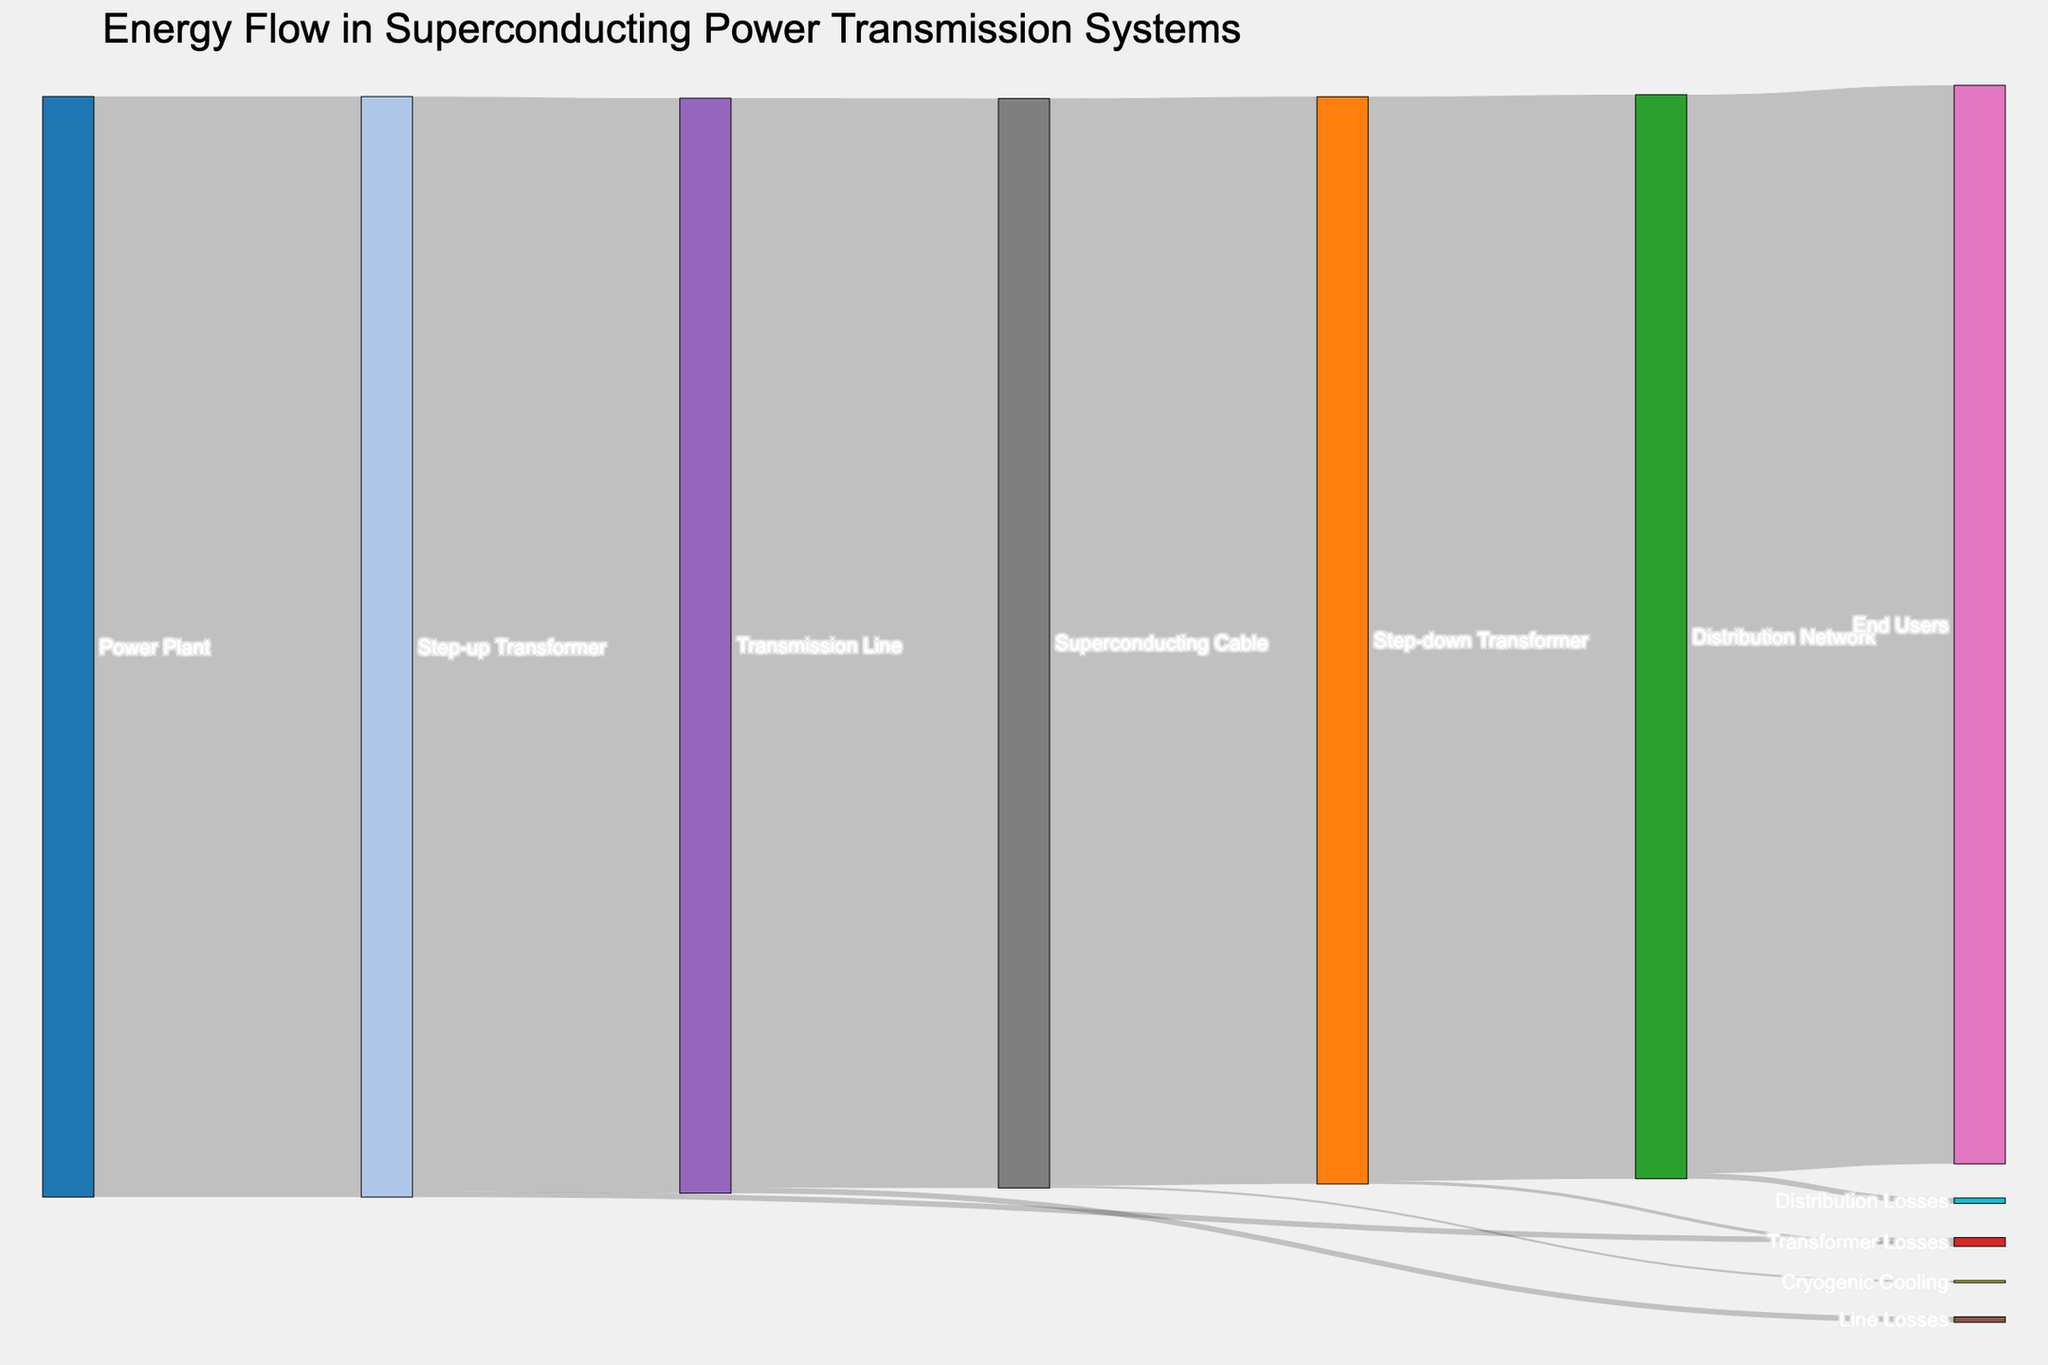What is the title of the Sankey Diagram? The title of the Sankey Diagram is located at the top of the figure and provides an overview of the chart. Reading it will give us the title.
Answer: Energy Flow in Superconducting Power Transmission Systems How much energy is used by the end users? The value next to the "End Users" node in the Sankey Diagram represents the amount of energy received by the end users, as derived from the flow into this node.
Answer: 980 What is the loss of energy in the step-up transformer? Look at the node labeled "Step-up Transformer" and find the link labeled "Transformer Losses" to see how much energy is lost.
Answer: 5 Which stage has the highest energy loss? Compare the values of energy losses at each stage as indicated by the links associated with losses (e.g., "Transformer Losses", "Line Losses", etc.).
Answer: Step-up Transformer How much energy is lost in the transmission line? Find the value for the link between "Transmission Line" and "Line Losses". This will show the energy lost in the transmission line.
Answer: 5 What is the combined energy loss in the superconducting cable and the step-down transformer? Locate the energy loss values associated with "Superconducting Cable" (Cryogenic Cooling) and "Step-down Transformer" (Transformer Losses). Sum these values: 2 (Cryogenic Cooling) + 3 (Transformer Losses).
Answer: 5 How does the loss in the distribution network compare to the loss in cryogenic cooling? Compare the value of energy loss in "Distribution Network" (Distribution Losses) with that in "Superconducting Cable" (Cryogenic Cooling). The distribution network losses are 5 and cryogenic cooling losses are 2.
Answer: Distribution Network losses are greater What is the total energy lost from the power plant to the end users? Sum up the energy losses at each stage: 5 (Step-up Transformer) + 5 (Transmission Line) + 2 (Cryogenic Cooling) + 3 (Step-down Transformer) + 5 (Distribution Network).
Answer: 20 How much energy is transmitted from the step-up transformer to the transmission line? Find the link from "Step-up Transformer" to "Transmission Line" and read the value indicated.
Answer: 995 